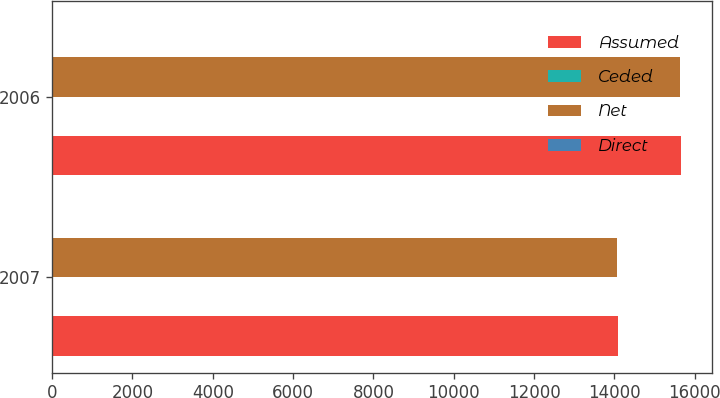Convert chart to OTSL. <chart><loc_0><loc_0><loc_500><loc_500><stacked_bar_chart><ecel><fcel>2007<fcel>2006<nl><fcel>Assumed<fcel>14089<fcel>15652<nl><fcel>Ceded<fcel>1<fcel>1<nl><fcel>Net<fcel>14071<fcel>15633<nl><fcel>Direct<fcel>19<fcel>20<nl></chart> 